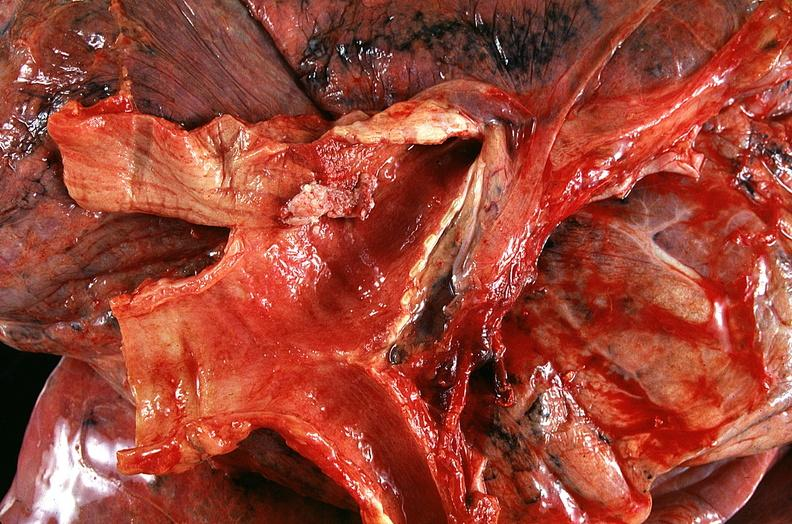s respiratory present?
Answer the question using a single word or phrase. Yes 